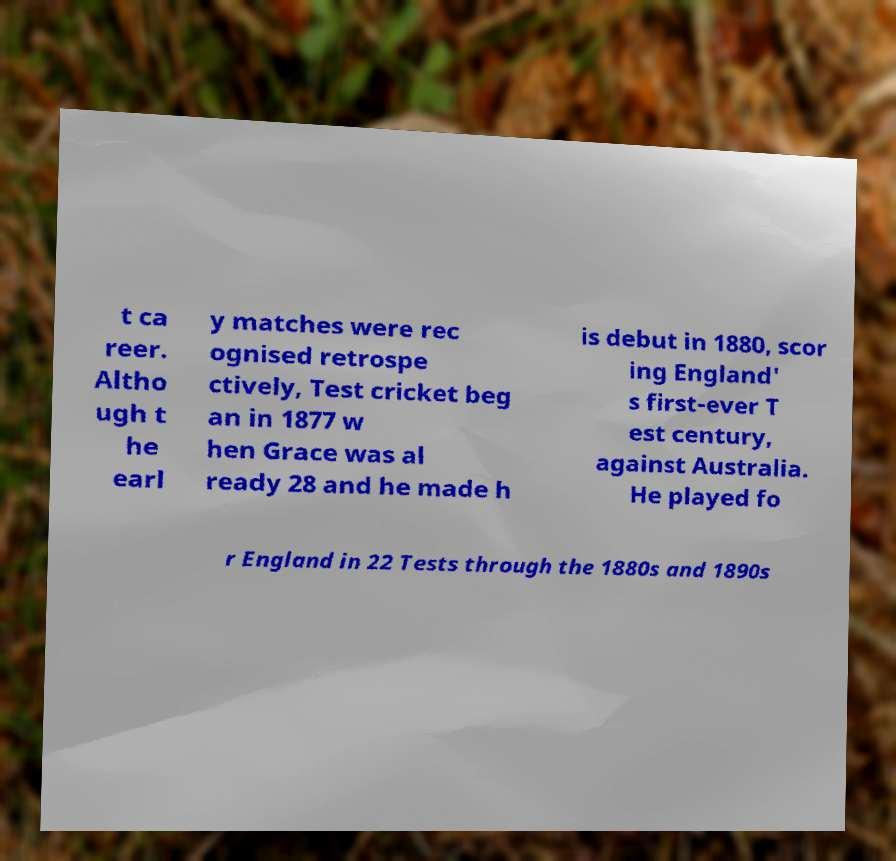Can you read and provide the text displayed in the image?This photo seems to have some interesting text. Can you extract and type it out for me? t ca reer. Altho ugh t he earl y matches were rec ognised retrospe ctively, Test cricket beg an in 1877 w hen Grace was al ready 28 and he made h is debut in 1880, scor ing England' s first-ever T est century, against Australia. He played fo r England in 22 Tests through the 1880s and 1890s 